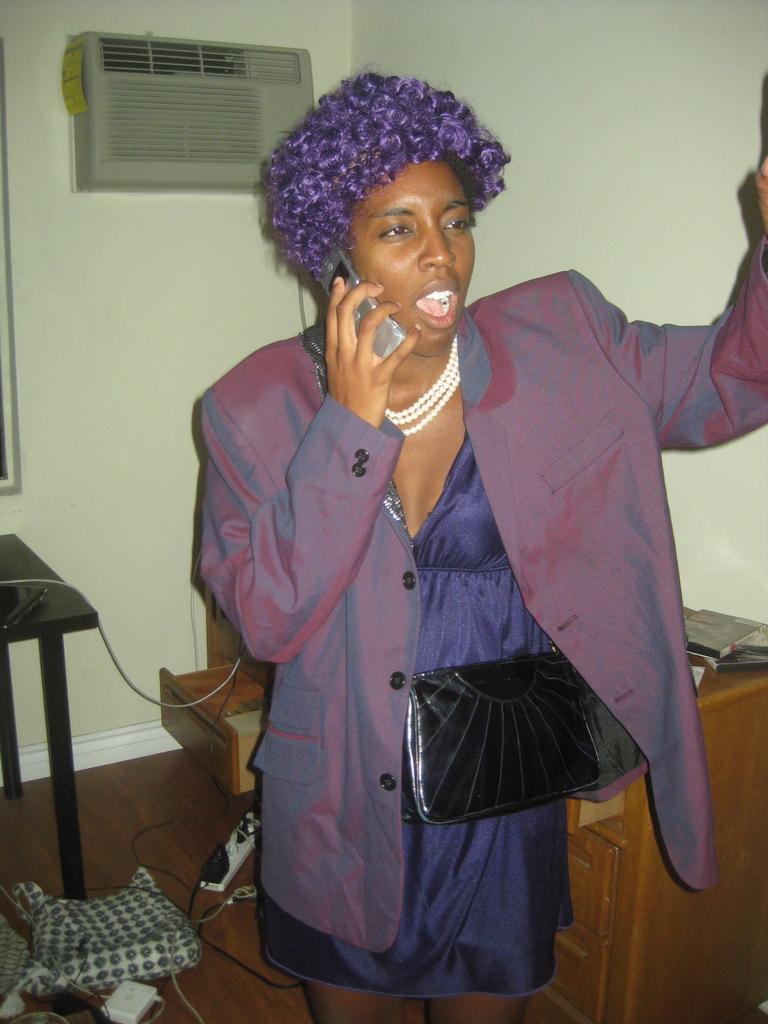Please provide a concise description of this image. It is an image where a woman wearing purple color dress is speaking on a phone ,beside her there is a table ,in the background there is an conditioner and a wall. 